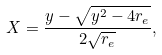Convert formula to latex. <formula><loc_0><loc_0><loc_500><loc_500>X = \frac { y - \sqrt { y ^ { 2 } - 4 r _ { e } } } { 2 \sqrt { r _ { e } } } ,</formula> 